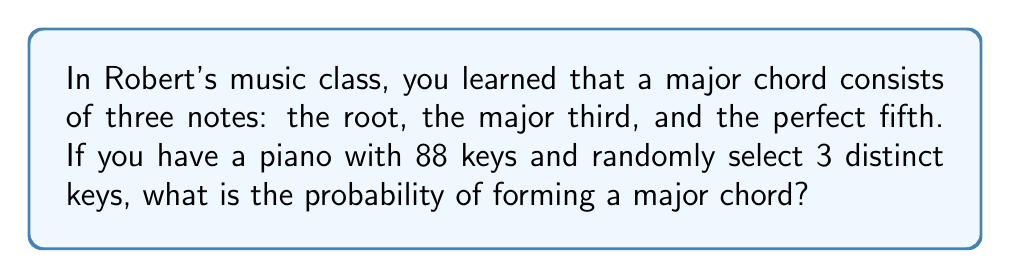Can you answer this question? Let's approach this step-by-step:

1) First, we need to calculate the total number of ways to select 3 distinct keys out of 88. This is given by the combination formula:

   $$\binom{88}{3} = \frac{88!}{3!(88-3)!} = \frac{88!}{3!85!} = 133,616$$

2) Now, we need to calculate how many ways we can form a major chord. To do this:
   - We can choose any of the 88 keys as the root.
   - The major third is always 4 semitones above the root.
   - The perfect fifth is always 7 semitones above the root.

3) However, we need to consider the limitations:
   - If we choose one of the top 7 keys as the root, we can't form a complete major chord.

4) So, the number of ways to form a major chord is:
   $$88 - 7 = 81$$

5) The probability is thus:

   $$P(\text{major chord}) = \frac{\text{favorable outcomes}}{\text{total outcomes}} = \frac{81}{133,616}$$

6) Simplifying this fraction:

   $$\frac{81}{133,616} = \frac{81}{133,616} \cdot \frac{1}{1} = \frac{81}{133,616} = \frac{1}{1,650.81...}$$
Answer: $\frac{1}{1,651}$ (rounded to nearest integer denominator) 